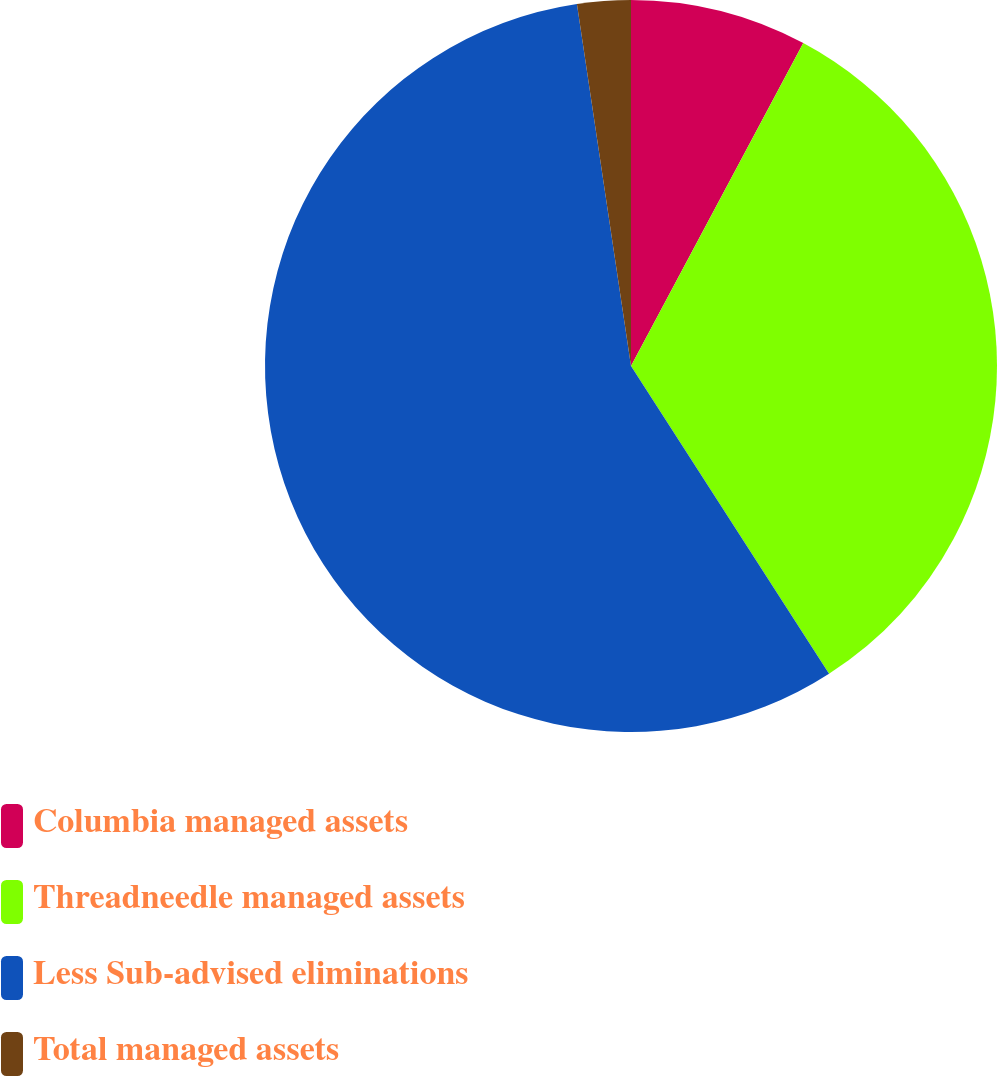Convert chart to OTSL. <chart><loc_0><loc_0><loc_500><loc_500><pie_chart><fcel>Columbia managed assets<fcel>Threadneedle managed assets<fcel>Less Sub-advised eliminations<fcel>Total managed assets<nl><fcel>7.8%<fcel>33.1%<fcel>56.74%<fcel>2.36%<nl></chart> 